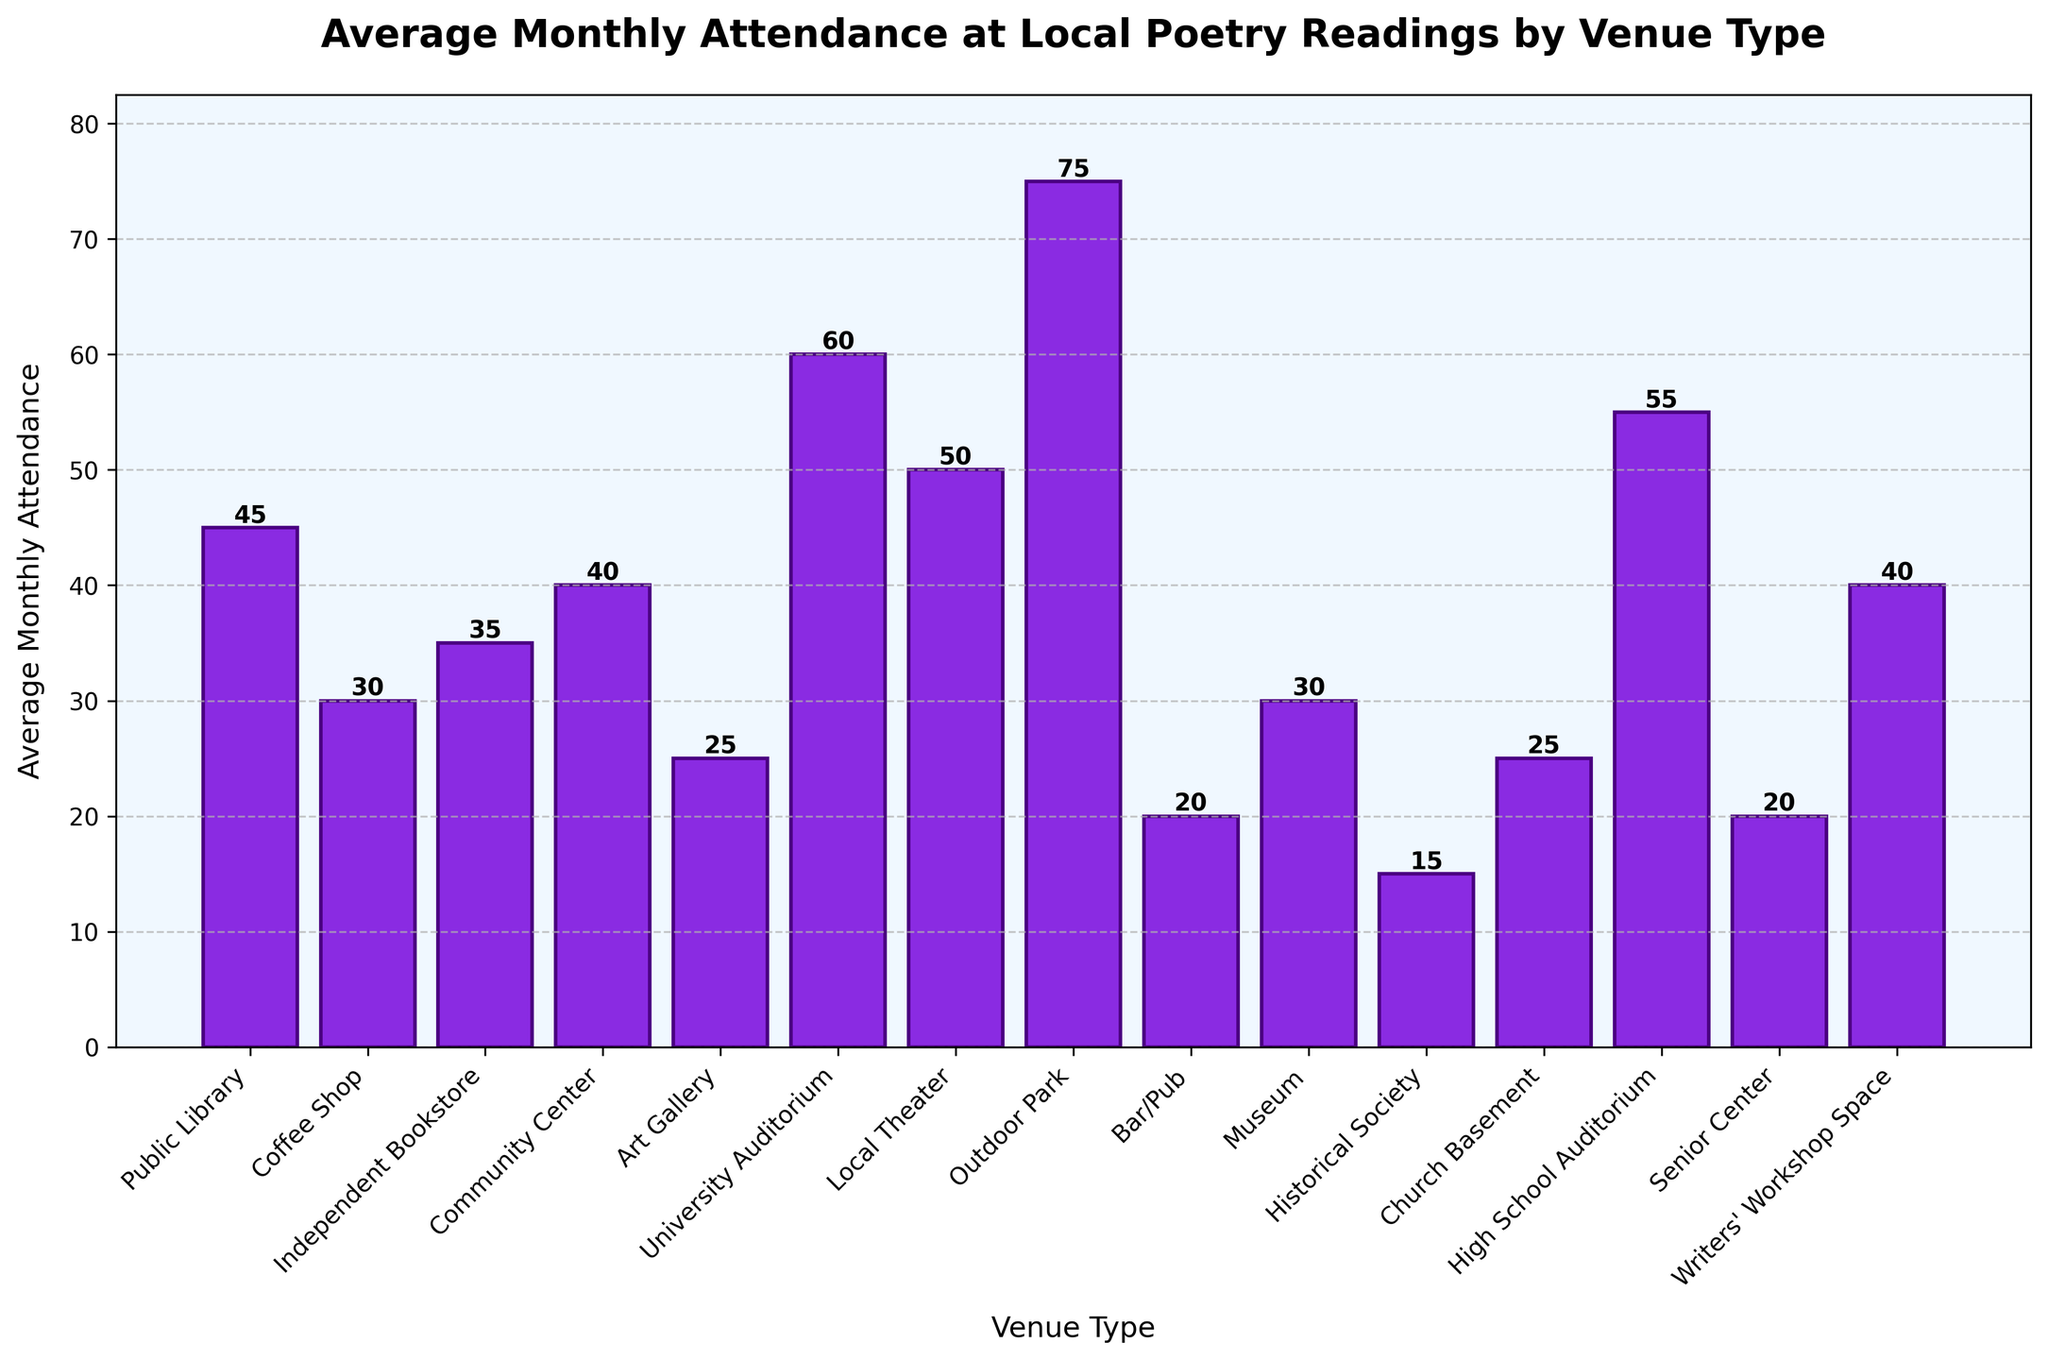Which venue type has the highest average monthly attendance? The highest bar represents the highest average monthly attendance. It is clearly the Outdoor Park.
Answer: Outdoor Park Which venue type has the lowest average monthly attendance? The shortest bar represents the lowest average monthly attendance. The Historical Society has the shortest bar.
Answer: Historical Society Compare the average monthly attendance between Public Library and Coffee Shop. Which one has more, and by how much? The bar for Public Library is higher than that for Coffee Shop. Public Library has an attendance of 45, and Coffee Shop has 30. The difference is 45 - 30 = 15.
Answer: Public Library by 15 What is the average monthly attendance for venues with "auditorium" in their names? The University Auditorium and High School Auditorium have 60 and 55 respectively. The average is (60 + 55) / 2 = 57.5
Answer: 57.5 Are there more people on average at poetry readings in outdoor venues or indoor venues like museums and art galleries? The average attendance for outdoor venues (like Outdoor Park) is higher than for indoor venues (like Museum and Art Gallery). Outdoor Park has 75, while Museum has 30 and Art Gallery has 25.
Answer: Outdoor venues Which venue has the second highest average monthly attendance? The second highest bar after Outdoor Park is that of the University Auditorium.
Answer: University Auditorium What is the combined average monthly attendance of all community-centric venues (Community Center, Senior Center, Community Library)? The averages are Community Center (40), Senior Center (20), and Public Library (45). Combined attendance is 40 + 20 + 45 = 105.
Answer: 105 On average, how much higher is attendance at outdoor parks compared to bars/pubs? Outdoor Park attendance is 75 and Bar/Pub is 20. The difference is 75 - 20 = 55.
Answer: 55 Is the average attendance at a University Auditorium event higher or lower than that at a Local Theater event and by how much? University Auditorium has an average attendance of 60, and Local Theater has 50. The difference is 60 - 50 = 10.
Answer: Higher by 10 What is the total average monthly attendance if poetry readings are held in Coffee Shops, Independent Bookstores, and Museums combined? Coffee Shop has 30, Independent Bookstore has 35, and Museum has 30. The total is 30 + 35 + 30 = 95.
Answer: 95 